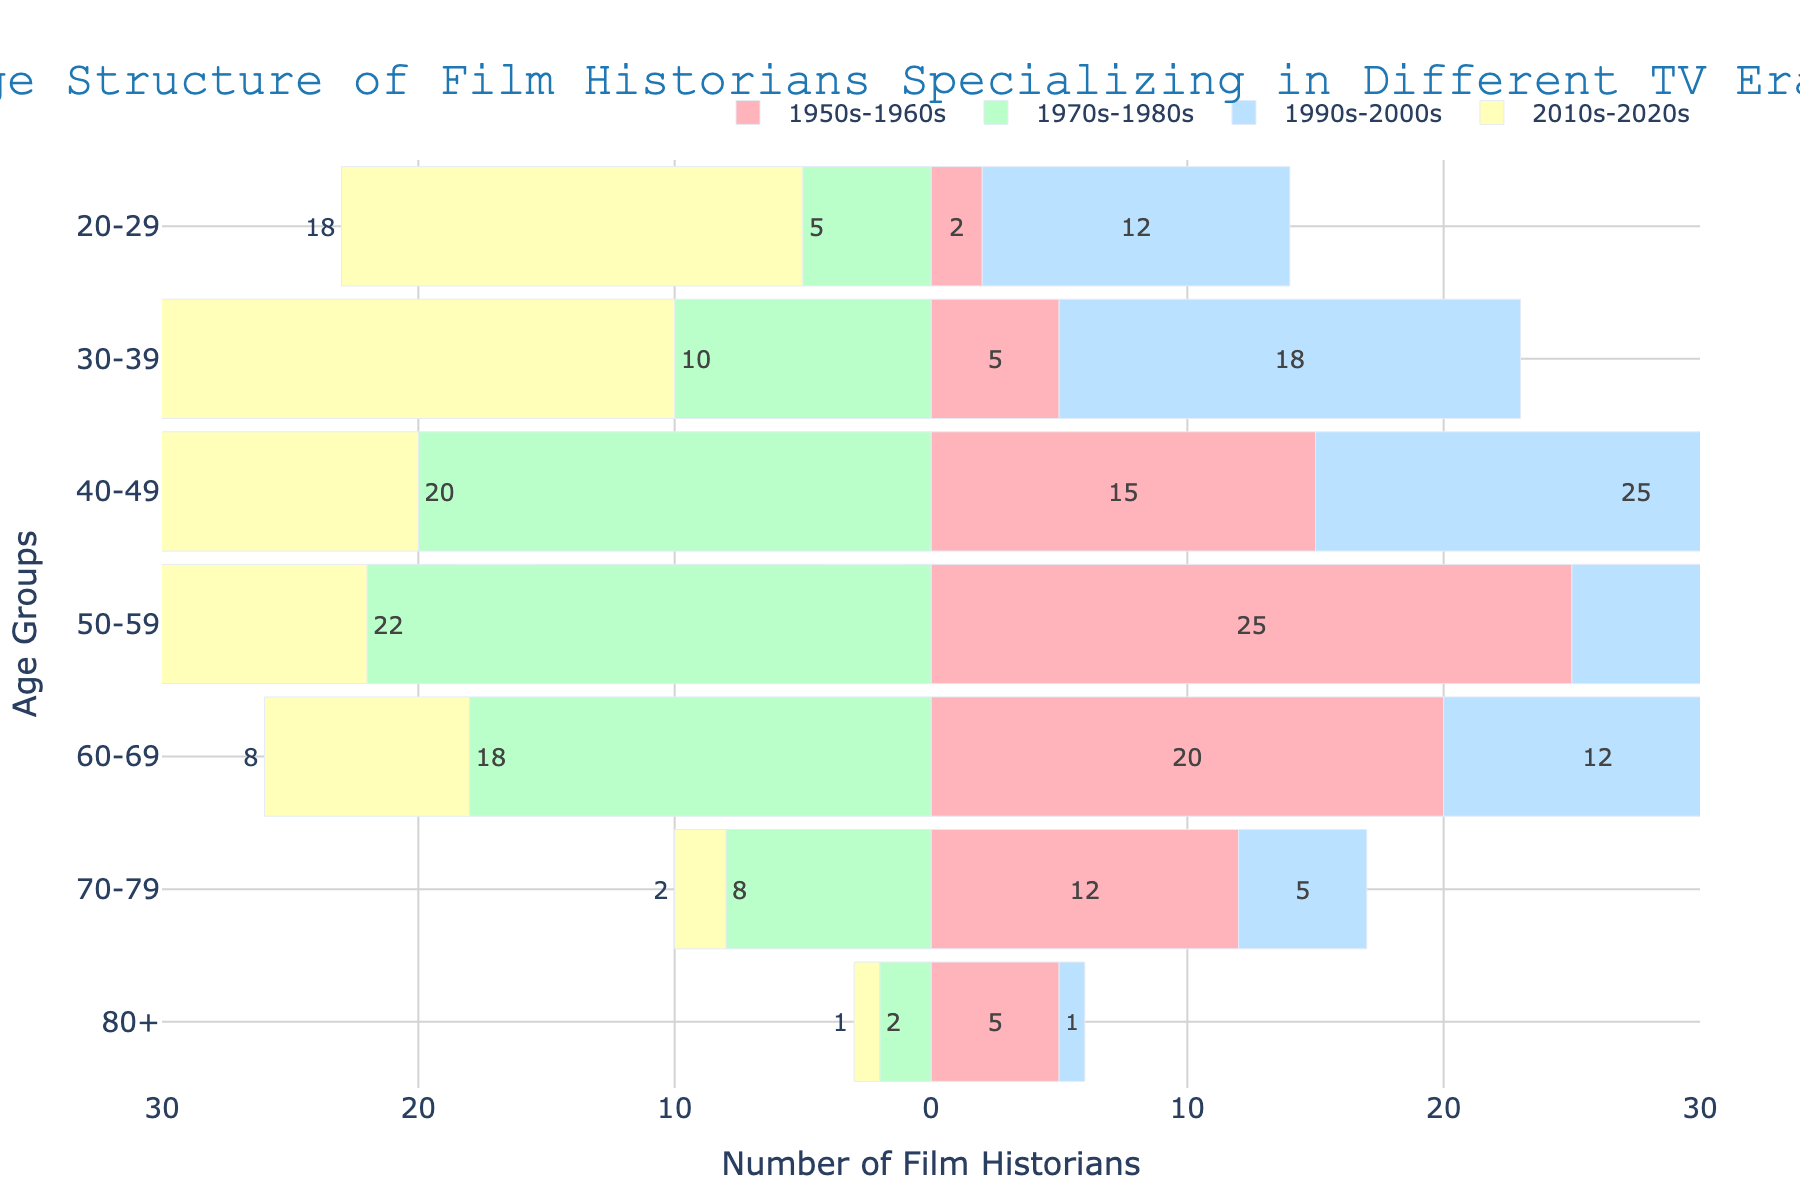What is the age group with the highest number of film historians specializing in the 1950s-1960s? The tallest or longest bar for the 1950s-1960s section corresponds to the 50-59 age group, indicating the highest number of film historians.
Answer: 50-59 How many film historians specialize in the 1990s-2000s era and are in the 40-49 age group? Look for the bar associated with the 1990s-2000s era in the 40-49 age group and read its length.
Answer: 25 Which era has the smallest number of film historians aged 70-79? Compare the lengths of the bars for the 70-79 age group across all eras. The shortest bar belongs to the 2010s-2020s era.
Answer: 2010s-2020s In terms of total film historians, which two age groups contribute equally for the 2010s-2020s era? Compare the heights or lengths of the bars for the 2010s-2020s era. The 50-59 and 60-69 age groups have similar lengths.
Answer: 50-59 and 60-69 How does the number of film historians aged 50-59 in the 1950s-1960s era compare to those aged 60-69 in the same era? Compare the lengths of the bars for the 50-59 and 60-69 age groups in the 1950s-1960s era. The bar for 50-59 is longer.
Answer: More in 50-59 What's the total number of film historians specializing in the 1970s-1980s era within the age groups from 20-29 and 30-39? Sum the values of the 20-29 and 30-39 age groups for the 1970s-1980s era (5 + 10 = 15).
Answer: 15 Which age group has the largest difference in the number of film historians between the 1990s-2000s and 2010s-2020s eras? Calculate the differences for each age group and identify the largest. The 40-49 age group has the largest difference (25 - 20 = 5).
Answer: 40-49 What can you infer about the age distribution of film historians specializing in the 1950s-1960s era compared to those in the 2010s-2020s era? Analyses show that the 1950s-1960s specialization has older film historians predominantly, while the 2010s-2020s specialization has a relatively younger population.
Answer: 1950s-1960s are older, 2010s-2020s are younger Which era shows a peak in the number of film historians in the 30-39 age group? Look for the tallest or longest bar in the 30-39 age group. The 2010s-2020s era has the highest number.
Answer: 2010s-2020s 